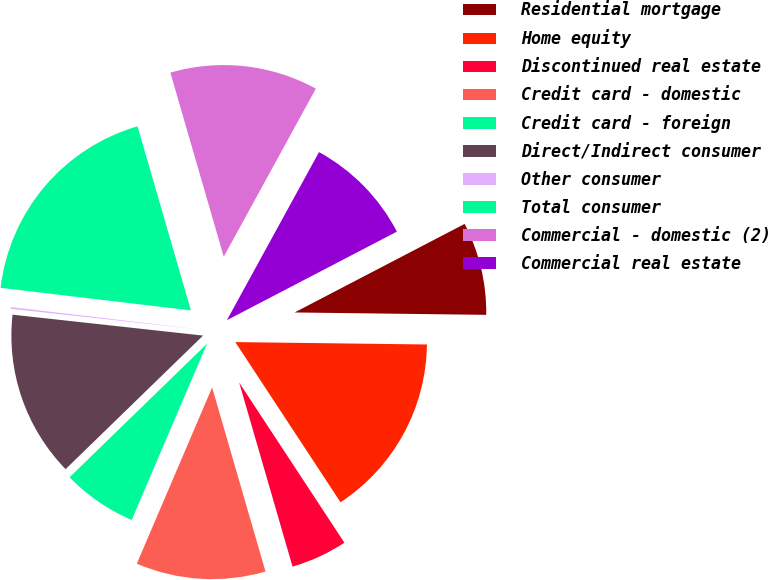Convert chart. <chart><loc_0><loc_0><loc_500><loc_500><pie_chart><fcel>Residential mortgage<fcel>Home equity<fcel>Discontinued real estate<fcel>Credit card - domestic<fcel>Credit card - foreign<fcel>Direct/Indirect consumer<fcel>Other consumer<fcel>Total consumer<fcel>Commercial - domestic (2)<fcel>Commercial real estate<nl><fcel>7.84%<fcel>15.55%<fcel>4.76%<fcel>10.92%<fcel>6.3%<fcel>14.01%<fcel>0.14%<fcel>18.63%<fcel>12.47%<fcel>9.38%<nl></chart> 